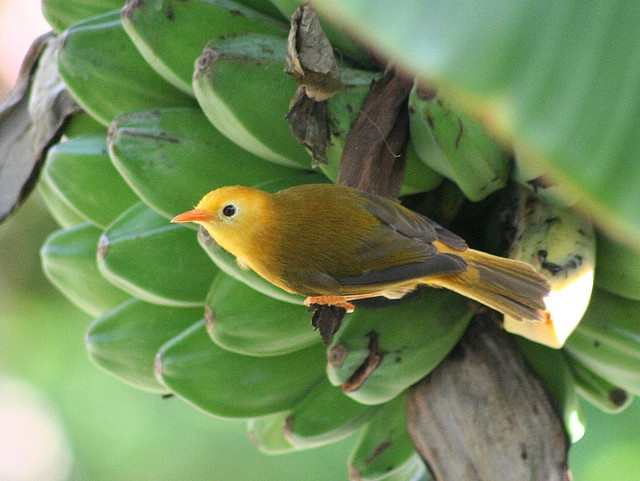Describe the objects in this image and their specific colors. I can see banana in tan, green, and darkgreen tones, bird in tan, olive, gray, and black tones, banana in tan, darkgreen, black, and green tones, banana in tan, green, lightgreen, and darkgray tones, and banana in tan, green, and olive tones in this image. 